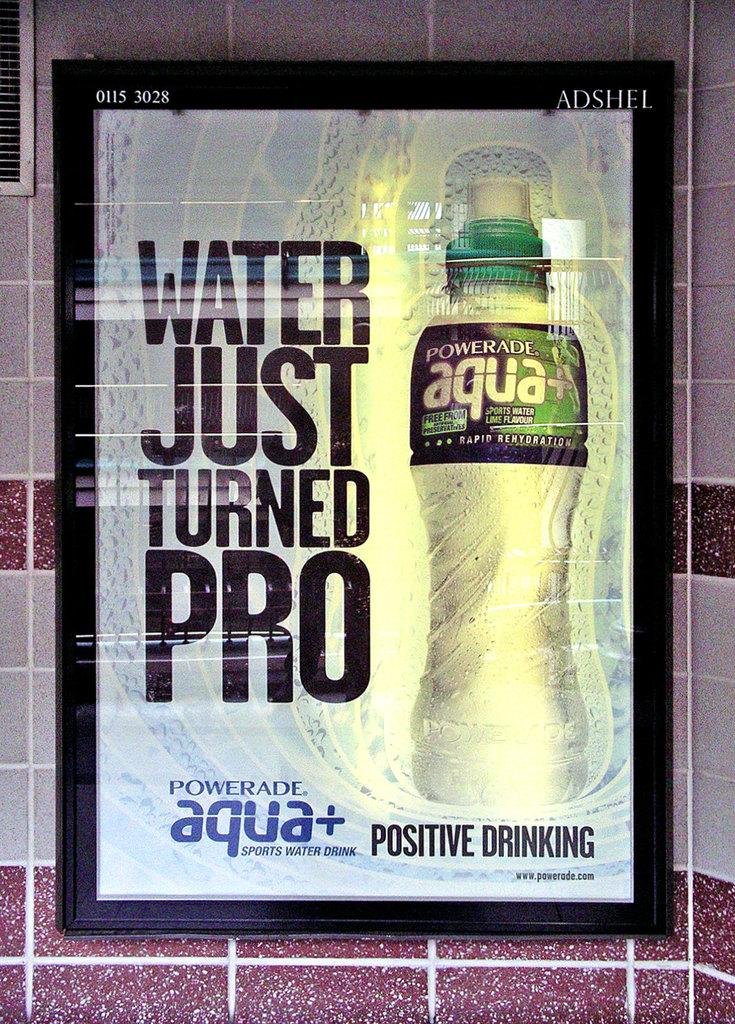<image>
Create a compact narrative representing the image presented. Powerade Aqua poster with the saying "Water Just Turned Pro". 